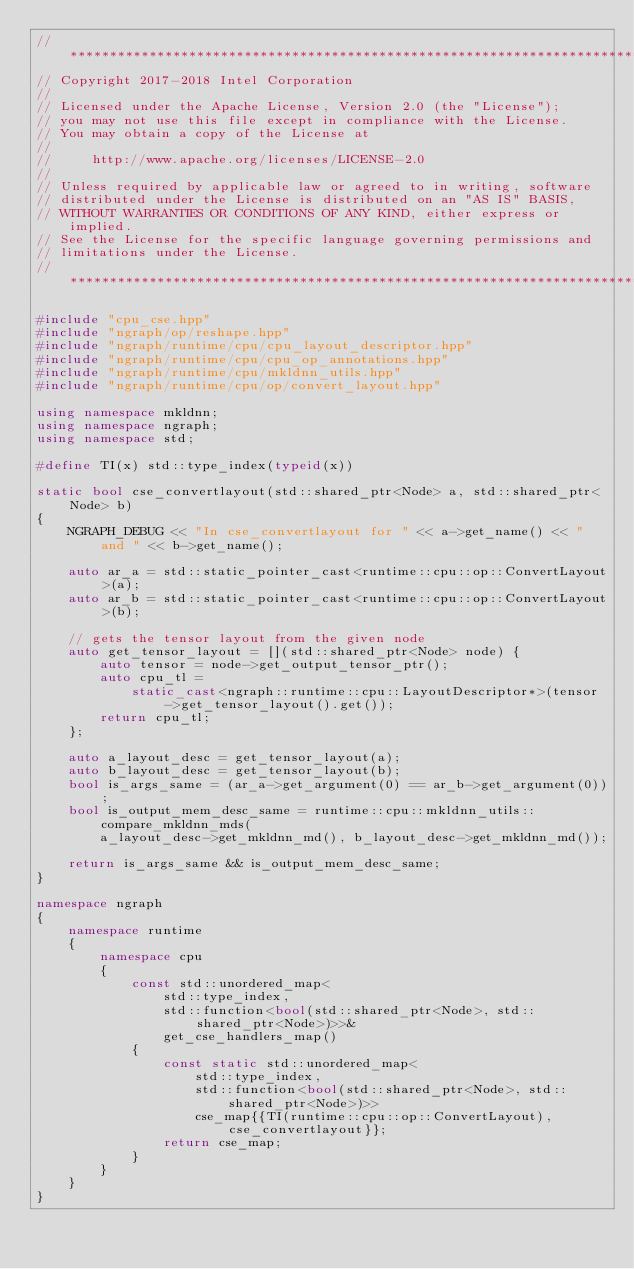<code> <loc_0><loc_0><loc_500><loc_500><_C++_>//*****************************************************************************
// Copyright 2017-2018 Intel Corporation
//
// Licensed under the Apache License, Version 2.0 (the "License");
// you may not use this file except in compliance with the License.
// You may obtain a copy of the License at
//
//     http://www.apache.org/licenses/LICENSE-2.0
//
// Unless required by applicable law or agreed to in writing, software
// distributed under the License is distributed on an "AS IS" BASIS,
// WITHOUT WARRANTIES OR CONDITIONS OF ANY KIND, either express or implied.
// See the License for the specific language governing permissions and
// limitations under the License.
//*****************************************************************************

#include "cpu_cse.hpp"
#include "ngraph/op/reshape.hpp"
#include "ngraph/runtime/cpu/cpu_layout_descriptor.hpp"
#include "ngraph/runtime/cpu/cpu_op_annotations.hpp"
#include "ngraph/runtime/cpu/mkldnn_utils.hpp"
#include "ngraph/runtime/cpu/op/convert_layout.hpp"

using namespace mkldnn;
using namespace ngraph;
using namespace std;

#define TI(x) std::type_index(typeid(x))

static bool cse_convertlayout(std::shared_ptr<Node> a, std::shared_ptr<Node> b)
{
    NGRAPH_DEBUG << "In cse_convertlayout for " << a->get_name() << " and " << b->get_name();

    auto ar_a = std::static_pointer_cast<runtime::cpu::op::ConvertLayout>(a);
    auto ar_b = std::static_pointer_cast<runtime::cpu::op::ConvertLayout>(b);

    // gets the tensor layout from the given node
    auto get_tensor_layout = [](std::shared_ptr<Node> node) {
        auto tensor = node->get_output_tensor_ptr();
        auto cpu_tl =
            static_cast<ngraph::runtime::cpu::LayoutDescriptor*>(tensor->get_tensor_layout().get());
        return cpu_tl;
    };

    auto a_layout_desc = get_tensor_layout(a);
    auto b_layout_desc = get_tensor_layout(b);
    bool is_args_same = (ar_a->get_argument(0) == ar_b->get_argument(0));
    bool is_output_mem_desc_same = runtime::cpu::mkldnn_utils::compare_mkldnn_mds(
        a_layout_desc->get_mkldnn_md(), b_layout_desc->get_mkldnn_md());

    return is_args_same && is_output_mem_desc_same;
}

namespace ngraph
{
    namespace runtime
    {
        namespace cpu
        {
            const std::unordered_map<
                std::type_index,
                std::function<bool(std::shared_ptr<Node>, std::shared_ptr<Node>)>>&
                get_cse_handlers_map()
            {
                const static std::unordered_map<
                    std::type_index,
                    std::function<bool(std::shared_ptr<Node>, std::shared_ptr<Node>)>>
                    cse_map{{TI(runtime::cpu::op::ConvertLayout), cse_convertlayout}};
                return cse_map;
            }
        }
    }
}
</code> 